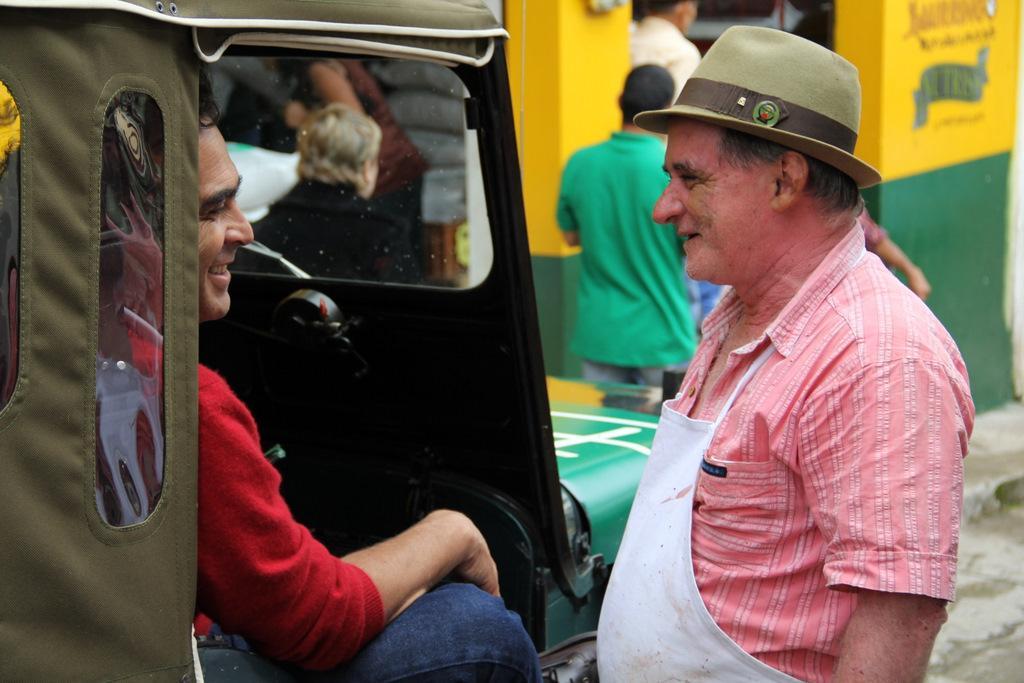Can you describe this image briefly? In this image there is a person standing with a smile on his face, in front of him there is another person sitting in the jeep is having a smile on his face, in front of him there are a few other people walking on the pavement and there is a pillar and there is some painting on the wall. 